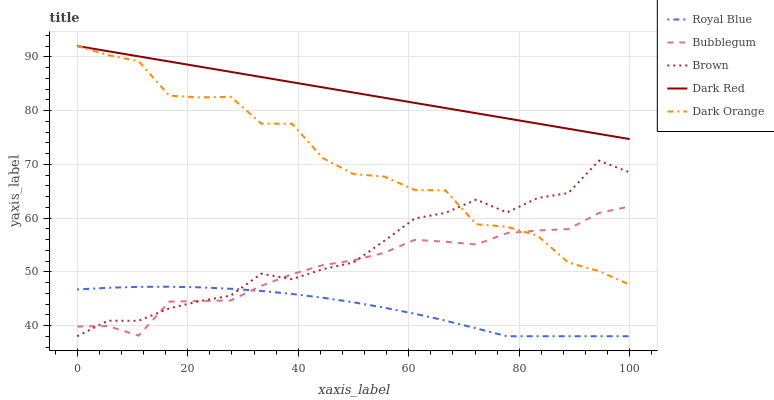Does Royal Blue have the minimum area under the curve?
Answer yes or no. Yes. Does Dark Red have the maximum area under the curve?
Answer yes or no. Yes. Does Dark Red have the minimum area under the curve?
Answer yes or no. No. Does Royal Blue have the maximum area under the curve?
Answer yes or no. No. Is Dark Red the smoothest?
Answer yes or no. Yes. Is Dark Orange the roughest?
Answer yes or no. Yes. Is Royal Blue the smoothest?
Answer yes or no. No. Is Royal Blue the roughest?
Answer yes or no. No. Does Royal Blue have the lowest value?
Answer yes or no. Yes. Does Dark Red have the lowest value?
Answer yes or no. No. Does Dark Red have the highest value?
Answer yes or no. Yes. Does Royal Blue have the highest value?
Answer yes or no. No. Is Brown less than Dark Red?
Answer yes or no. Yes. Is Dark Red greater than Brown?
Answer yes or no. Yes. Does Bubblegum intersect Royal Blue?
Answer yes or no. Yes. Is Bubblegum less than Royal Blue?
Answer yes or no. No. Is Bubblegum greater than Royal Blue?
Answer yes or no. No. Does Brown intersect Dark Red?
Answer yes or no. No. 